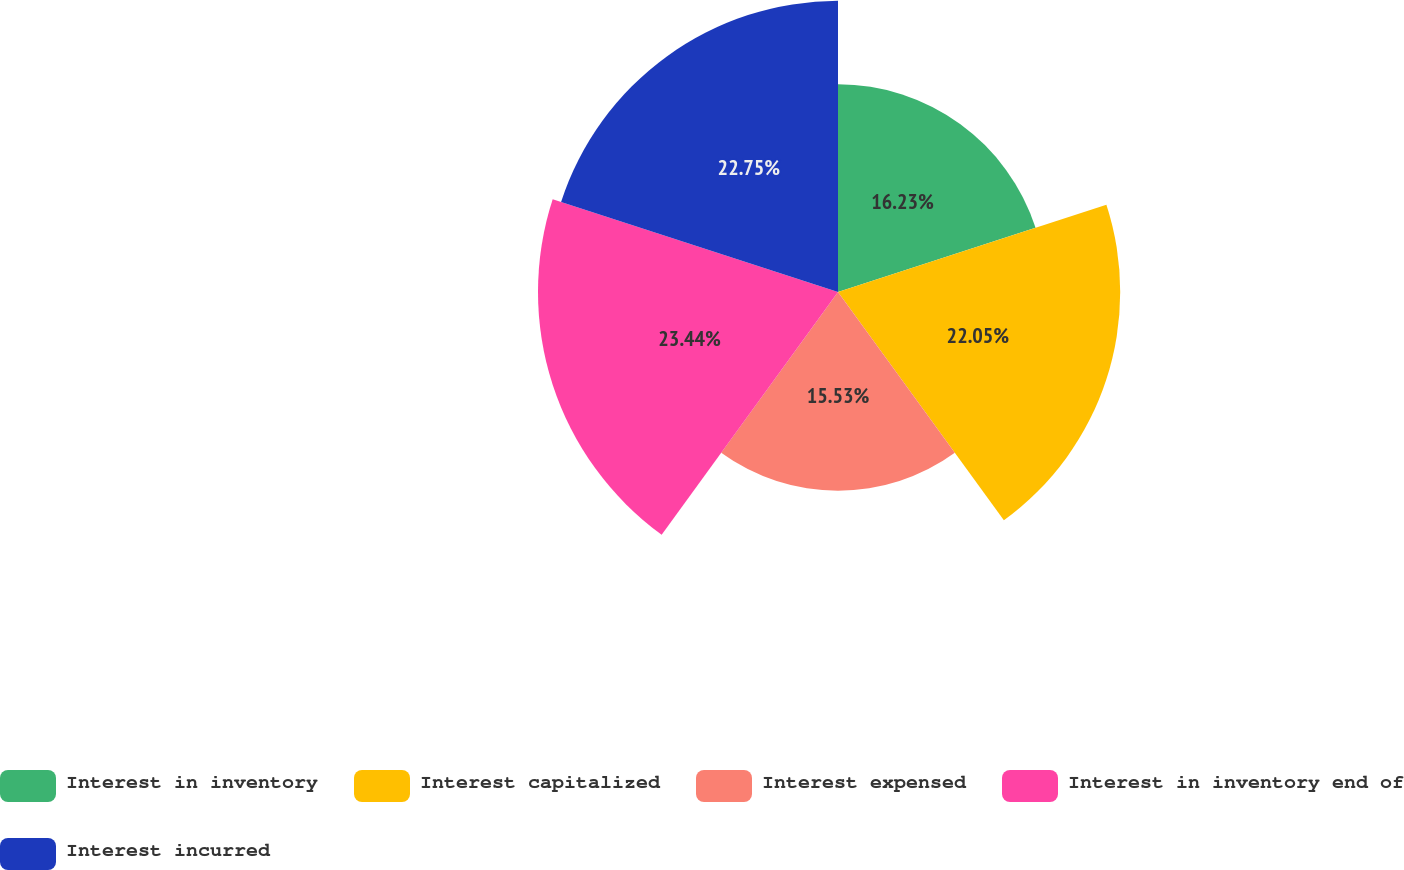Convert chart. <chart><loc_0><loc_0><loc_500><loc_500><pie_chart><fcel>Interest in inventory<fcel>Interest capitalized<fcel>Interest expensed<fcel>Interest in inventory end of<fcel>Interest incurred<nl><fcel>16.23%<fcel>22.05%<fcel>15.53%<fcel>23.44%<fcel>22.75%<nl></chart> 